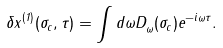Convert formula to latex. <formula><loc_0><loc_0><loc_500><loc_500>\delta x ^ { ( 1 ) } _ { \| } ( \sigma _ { c } , \tau ) = \int d \omega D ^ { \| } _ { \omega } ( \sigma _ { c } ) e ^ { - i \omega \tau } .</formula> 